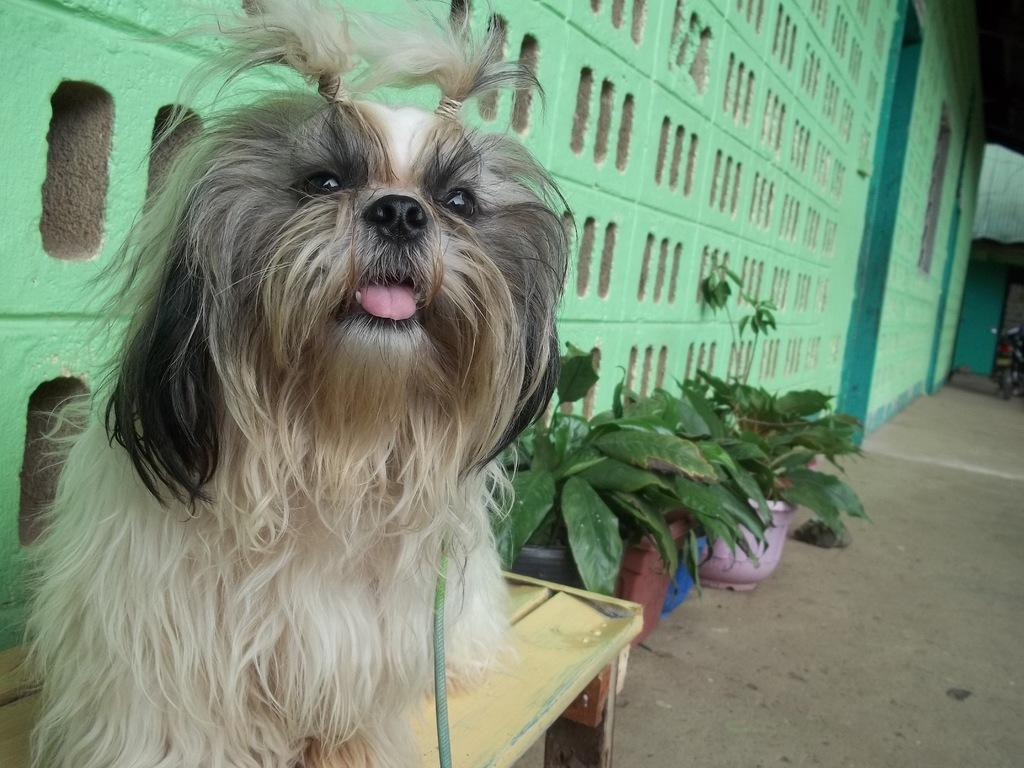What is the main subject in the foreground of the image? There is a dog in the foreground of the image. What else can be seen in the image besides the dog? There are many plants in the image. What is visible in the background of the image? There is a wall in the background of the image. Where is the doll during the recess in the image? There is no doll or recess present in the image. 